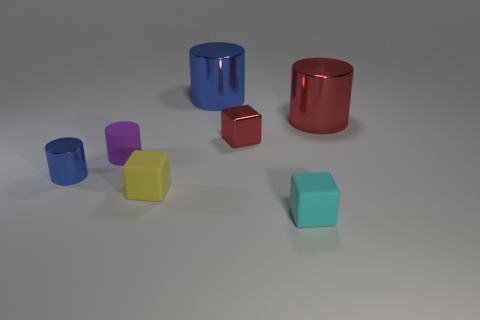Add 2 tiny gray things. How many objects exist? 9 Subtract all cylinders. How many objects are left? 3 Subtract 0 green cubes. How many objects are left? 7 Subtract all big blue objects. Subtract all purple matte objects. How many objects are left? 5 Add 6 tiny shiny blocks. How many tiny shiny blocks are left? 7 Add 2 purple cylinders. How many purple cylinders exist? 3 